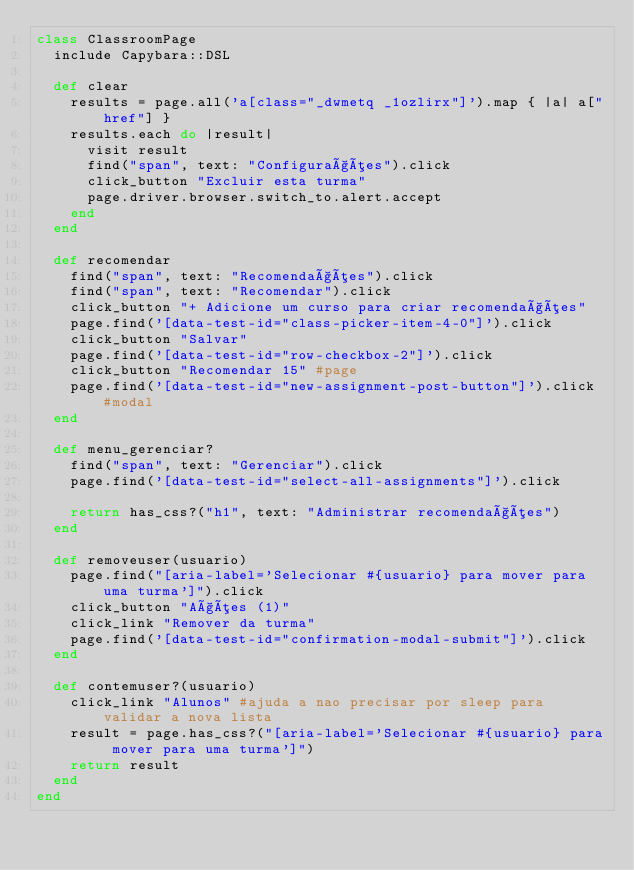Convert code to text. <code><loc_0><loc_0><loc_500><loc_500><_Ruby_>class ClassroomPage
  include Capybara::DSL

  def clear
    results = page.all('a[class="_dwmetq _1ozlirx"]').map { |a| a["href"] }
    results.each do |result|
      visit result
      find("span", text: "Configurações").click
      click_button "Excluir esta turma"
      page.driver.browser.switch_to.alert.accept
    end
  end

  def recomendar
    find("span", text: "Recomendações").click
    find("span", text: "Recomendar").click
    click_button "+ Adicione um curso para criar recomendações"
    page.find('[data-test-id="class-picker-item-4-0"]').click
    click_button "Salvar"
    page.find('[data-test-id="row-checkbox-2"]').click
    click_button "Recomendar 15" #page
    page.find('[data-test-id="new-assignment-post-button"]').click #modal
  end

  def menu_gerenciar?
    find("span", text: "Gerenciar").click
    page.find('[data-test-id="select-all-assignments"]').click

    return has_css?("h1", text: "Administrar recomendações")
  end

  def removeuser(usuario)
    page.find("[aria-label='Selecionar #{usuario} para mover para uma turma']").click
    click_button "Ações (1)"
    click_link "Remover da turma"
    page.find('[data-test-id="confirmation-modal-submit"]').click
  end

  def contemuser?(usuario)
    click_link "Alunos" #ajuda a nao precisar por sleep para validar a nova lista
    result = page.has_css?("[aria-label='Selecionar #{usuario} para mover para uma turma']")
    return result
  end
end
</code> 